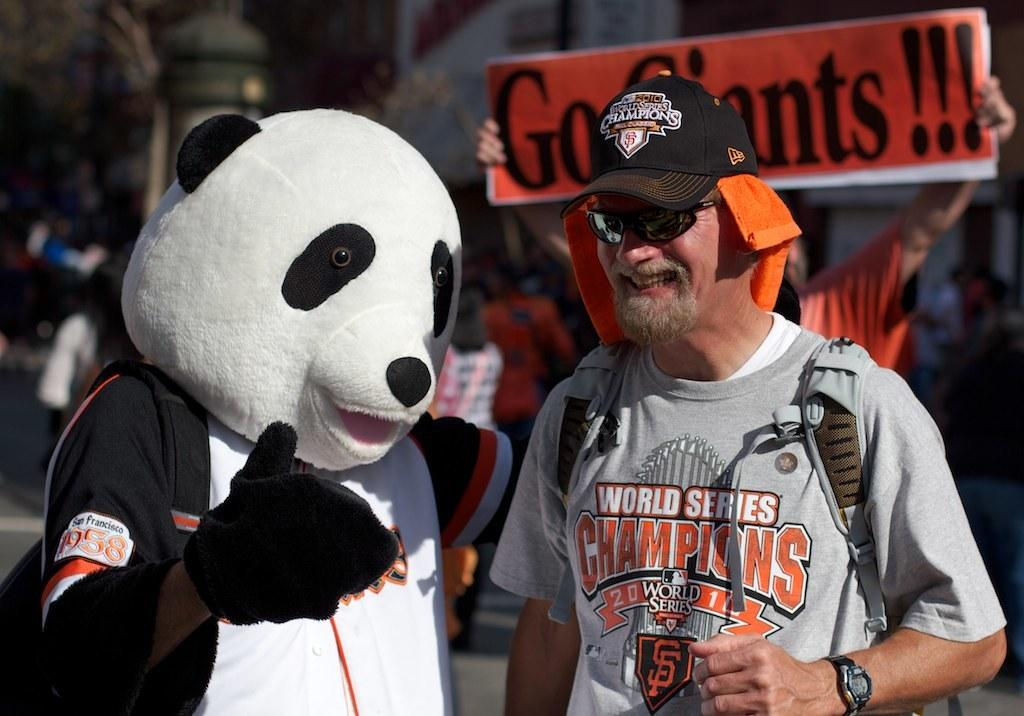<image>
Summarize the visual content of the image. Sports fan in gray shirt with Champions in orange lettering on the front. 